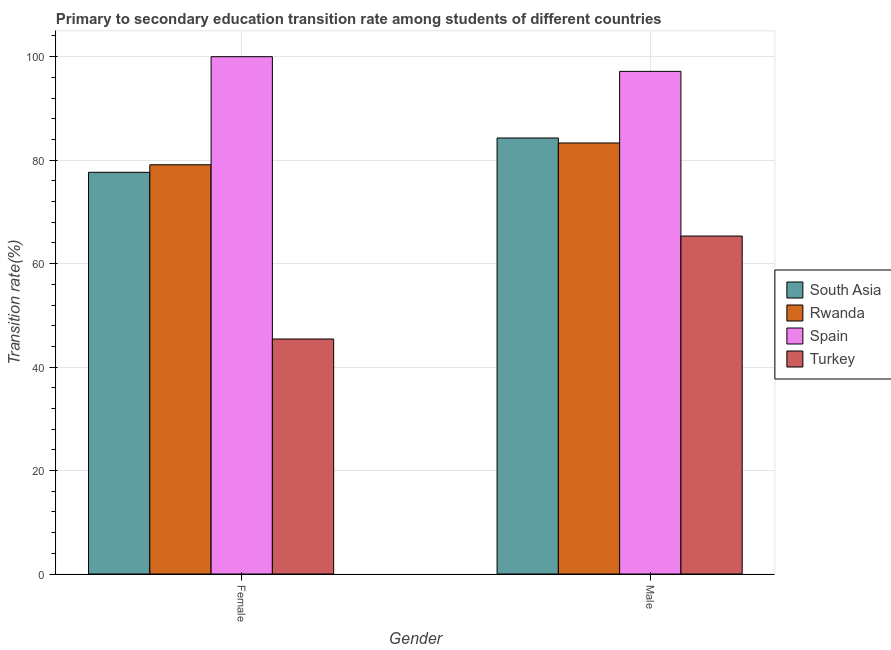Are the number of bars per tick equal to the number of legend labels?
Ensure brevity in your answer.  Yes. Are the number of bars on each tick of the X-axis equal?
Ensure brevity in your answer.  Yes. How many bars are there on the 1st tick from the left?
Your response must be concise. 4. How many bars are there on the 2nd tick from the right?
Make the answer very short. 4. What is the transition rate among male students in Turkey?
Your answer should be very brief. 65.33. Across all countries, what is the minimum transition rate among female students?
Offer a very short reply. 45.43. In which country was the transition rate among male students maximum?
Offer a very short reply. Spain. In which country was the transition rate among female students minimum?
Offer a terse response. Turkey. What is the total transition rate among male students in the graph?
Keep it short and to the point. 330.09. What is the difference between the transition rate among male students in Rwanda and that in Spain?
Make the answer very short. -13.85. What is the difference between the transition rate among female students in Spain and the transition rate among male students in South Asia?
Offer a terse response. 15.72. What is the average transition rate among female students per country?
Your response must be concise. 75.55. What is the difference between the transition rate among male students and transition rate among female students in Rwanda?
Offer a very short reply. 4.21. What is the ratio of the transition rate among male students in Rwanda to that in Turkey?
Provide a succinct answer. 1.28. Is the transition rate among female students in Spain less than that in Turkey?
Your answer should be very brief. No. In how many countries, is the transition rate among female students greater than the average transition rate among female students taken over all countries?
Make the answer very short. 3. What does the 1st bar from the left in Female represents?
Offer a very short reply. South Asia. What does the 2nd bar from the right in Female represents?
Provide a succinct answer. Spain. How many bars are there?
Give a very brief answer. 8. How many countries are there in the graph?
Make the answer very short. 4. Where does the legend appear in the graph?
Your response must be concise. Center right. How many legend labels are there?
Offer a terse response. 4. What is the title of the graph?
Offer a very short reply. Primary to secondary education transition rate among students of different countries. Does "East Asia (all income levels)" appear as one of the legend labels in the graph?
Your response must be concise. No. What is the label or title of the Y-axis?
Provide a short and direct response. Transition rate(%). What is the Transition rate(%) of South Asia in Female?
Provide a succinct answer. 77.65. What is the Transition rate(%) of Rwanda in Female?
Your response must be concise. 79.11. What is the Transition rate(%) of Turkey in Female?
Provide a succinct answer. 45.43. What is the Transition rate(%) of South Asia in Male?
Keep it short and to the point. 84.28. What is the Transition rate(%) of Rwanda in Male?
Make the answer very short. 83.32. What is the Transition rate(%) of Spain in Male?
Your response must be concise. 97.17. What is the Transition rate(%) of Turkey in Male?
Make the answer very short. 65.33. Across all Gender, what is the maximum Transition rate(%) in South Asia?
Offer a very short reply. 84.28. Across all Gender, what is the maximum Transition rate(%) of Rwanda?
Make the answer very short. 83.32. Across all Gender, what is the maximum Transition rate(%) in Spain?
Ensure brevity in your answer.  100. Across all Gender, what is the maximum Transition rate(%) of Turkey?
Keep it short and to the point. 65.33. Across all Gender, what is the minimum Transition rate(%) in South Asia?
Give a very brief answer. 77.65. Across all Gender, what is the minimum Transition rate(%) in Rwanda?
Your answer should be very brief. 79.11. Across all Gender, what is the minimum Transition rate(%) of Spain?
Offer a terse response. 97.17. Across all Gender, what is the minimum Transition rate(%) of Turkey?
Keep it short and to the point. 45.43. What is the total Transition rate(%) in South Asia in the graph?
Your answer should be very brief. 161.94. What is the total Transition rate(%) of Rwanda in the graph?
Offer a very short reply. 162.42. What is the total Transition rate(%) of Spain in the graph?
Your answer should be very brief. 197.17. What is the total Transition rate(%) of Turkey in the graph?
Offer a very short reply. 110.75. What is the difference between the Transition rate(%) in South Asia in Female and that in Male?
Ensure brevity in your answer.  -6.63. What is the difference between the Transition rate(%) in Rwanda in Female and that in Male?
Ensure brevity in your answer.  -4.21. What is the difference between the Transition rate(%) of Spain in Female and that in Male?
Ensure brevity in your answer.  2.83. What is the difference between the Transition rate(%) of Turkey in Female and that in Male?
Keep it short and to the point. -19.9. What is the difference between the Transition rate(%) in South Asia in Female and the Transition rate(%) in Rwanda in Male?
Give a very brief answer. -5.67. What is the difference between the Transition rate(%) of South Asia in Female and the Transition rate(%) of Spain in Male?
Give a very brief answer. -19.52. What is the difference between the Transition rate(%) in South Asia in Female and the Transition rate(%) in Turkey in Male?
Make the answer very short. 12.32. What is the difference between the Transition rate(%) in Rwanda in Female and the Transition rate(%) in Spain in Male?
Ensure brevity in your answer.  -18.06. What is the difference between the Transition rate(%) in Rwanda in Female and the Transition rate(%) in Turkey in Male?
Make the answer very short. 13.78. What is the difference between the Transition rate(%) in Spain in Female and the Transition rate(%) in Turkey in Male?
Offer a terse response. 34.67. What is the average Transition rate(%) of South Asia per Gender?
Provide a succinct answer. 80.97. What is the average Transition rate(%) in Rwanda per Gender?
Your answer should be compact. 81.21. What is the average Transition rate(%) in Spain per Gender?
Your answer should be compact. 98.58. What is the average Transition rate(%) in Turkey per Gender?
Your answer should be very brief. 55.38. What is the difference between the Transition rate(%) of South Asia and Transition rate(%) of Rwanda in Female?
Your answer should be very brief. -1.45. What is the difference between the Transition rate(%) of South Asia and Transition rate(%) of Spain in Female?
Offer a terse response. -22.35. What is the difference between the Transition rate(%) in South Asia and Transition rate(%) in Turkey in Female?
Your answer should be compact. 32.22. What is the difference between the Transition rate(%) in Rwanda and Transition rate(%) in Spain in Female?
Make the answer very short. -20.89. What is the difference between the Transition rate(%) in Rwanda and Transition rate(%) in Turkey in Female?
Give a very brief answer. 33.68. What is the difference between the Transition rate(%) of Spain and Transition rate(%) of Turkey in Female?
Keep it short and to the point. 54.57. What is the difference between the Transition rate(%) of South Asia and Transition rate(%) of Rwanda in Male?
Provide a succinct answer. 0.97. What is the difference between the Transition rate(%) in South Asia and Transition rate(%) in Spain in Male?
Offer a very short reply. -12.88. What is the difference between the Transition rate(%) in South Asia and Transition rate(%) in Turkey in Male?
Your answer should be very brief. 18.96. What is the difference between the Transition rate(%) in Rwanda and Transition rate(%) in Spain in Male?
Keep it short and to the point. -13.85. What is the difference between the Transition rate(%) in Rwanda and Transition rate(%) in Turkey in Male?
Provide a short and direct response. 17.99. What is the difference between the Transition rate(%) in Spain and Transition rate(%) in Turkey in Male?
Give a very brief answer. 31.84. What is the ratio of the Transition rate(%) of South Asia in Female to that in Male?
Ensure brevity in your answer.  0.92. What is the ratio of the Transition rate(%) of Rwanda in Female to that in Male?
Ensure brevity in your answer.  0.95. What is the ratio of the Transition rate(%) in Spain in Female to that in Male?
Provide a short and direct response. 1.03. What is the ratio of the Transition rate(%) of Turkey in Female to that in Male?
Provide a succinct answer. 0.7. What is the difference between the highest and the second highest Transition rate(%) of South Asia?
Ensure brevity in your answer.  6.63. What is the difference between the highest and the second highest Transition rate(%) in Rwanda?
Your answer should be compact. 4.21. What is the difference between the highest and the second highest Transition rate(%) of Spain?
Your answer should be very brief. 2.83. What is the difference between the highest and the second highest Transition rate(%) of Turkey?
Offer a terse response. 19.9. What is the difference between the highest and the lowest Transition rate(%) in South Asia?
Offer a very short reply. 6.63. What is the difference between the highest and the lowest Transition rate(%) in Rwanda?
Give a very brief answer. 4.21. What is the difference between the highest and the lowest Transition rate(%) in Spain?
Make the answer very short. 2.83. What is the difference between the highest and the lowest Transition rate(%) of Turkey?
Give a very brief answer. 19.9. 